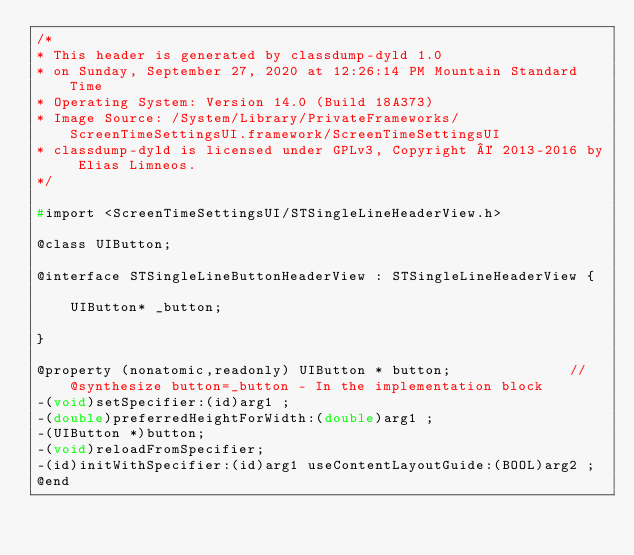Convert code to text. <code><loc_0><loc_0><loc_500><loc_500><_C_>/*
* This header is generated by classdump-dyld 1.0
* on Sunday, September 27, 2020 at 12:26:14 PM Mountain Standard Time
* Operating System: Version 14.0 (Build 18A373)
* Image Source: /System/Library/PrivateFrameworks/ScreenTimeSettingsUI.framework/ScreenTimeSettingsUI
* classdump-dyld is licensed under GPLv3, Copyright © 2013-2016 by Elias Limneos.
*/

#import <ScreenTimeSettingsUI/STSingleLineHeaderView.h>

@class UIButton;

@interface STSingleLineButtonHeaderView : STSingleLineHeaderView {

	UIButton* _button;

}

@property (nonatomic,readonly) UIButton * button;              //@synthesize button=_button - In the implementation block
-(void)setSpecifier:(id)arg1 ;
-(double)preferredHeightForWidth:(double)arg1 ;
-(UIButton *)button;
-(void)reloadFromSpecifier;
-(id)initWithSpecifier:(id)arg1 useContentLayoutGuide:(BOOL)arg2 ;
@end

</code> 